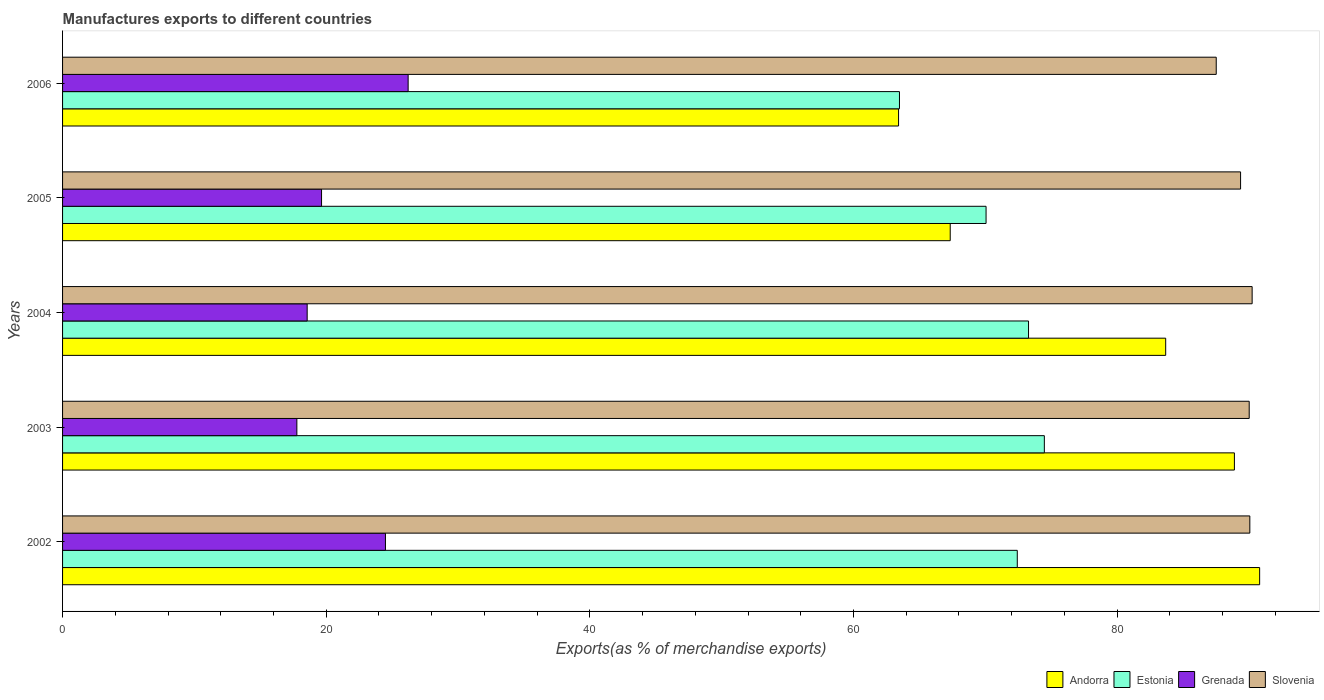How many different coloured bars are there?
Keep it short and to the point. 4. Are the number of bars per tick equal to the number of legend labels?
Provide a short and direct response. Yes. Are the number of bars on each tick of the Y-axis equal?
Provide a succinct answer. Yes. How many bars are there on the 3rd tick from the top?
Offer a terse response. 4. In how many cases, is the number of bars for a given year not equal to the number of legend labels?
Give a very brief answer. 0. What is the percentage of exports to different countries in Slovenia in 2005?
Provide a short and direct response. 89.36. Across all years, what is the maximum percentage of exports to different countries in Grenada?
Make the answer very short. 26.21. Across all years, what is the minimum percentage of exports to different countries in Slovenia?
Provide a succinct answer. 87.51. What is the total percentage of exports to different countries in Slovenia in the graph?
Your answer should be very brief. 447.19. What is the difference between the percentage of exports to different countries in Grenada in 2003 and that in 2004?
Your answer should be very brief. -0.78. What is the difference between the percentage of exports to different countries in Estonia in 2006 and the percentage of exports to different countries in Grenada in 2005?
Your response must be concise. 43.84. What is the average percentage of exports to different countries in Estonia per year?
Your answer should be very brief. 70.74. In the year 2006, what is the difference between the percentage of exports to different countries in Slovenia and percentage of exports to different countries in Andorra?
Provide a short and direct response. 24.1. What is the ratio of the percentage of exports to different countries in Grenada in 2003 to that in 2005?
Make the answer very short. 0.9. Is the percentage of exports to different countries in Andorra in 2002 less than that in 2005?
Ensure brevity in your answer.  No. Is the difference between the percentage of exports to different countries in Slovenia in 2002 and 2005 greater than the difference between the percentage of exports to different countries in Andorra in 2002 and 2005?
Make the answer very short. No. What is the difference between the highest and the second highest percentage of exports to different countries in Grenada?
Ensure brevity in your answer.  1.72. What is the difference between the highest and the lowest percentage of exports to different countries in Estonia?
Make the answer very short. 10.99. Is the sum of the percentage of exports to different countries in Andorra in 2002 and 2006 greater than the maximum percentage of exports to different countries in Slovenia across all years?
Your response must be concise. Yes. What does the 1st bar from the top in 2005 represents?
Keep it short and to the point. Slovenia. What does the 2nd bar from the bottom in 2005 represents?
Offer a terse response. Estonia. How many bars are there?
Ensure brevity in your answer.  20. Are all the bars in the graph horizontal?
Your response must be concise. Yes. Are the values on the major ticks of X-axis written in scientific E-notation?
Offer a very short reply. No. Does the graph contain any zero values?
Give a very brief answer. No. How are the legend labels stacked?
Give a very brief answer. Horizontal. What is the title of the graph?
Offer a terse response. Manufactures exports to different countries. What is the label or title of the X-axis?
Provide a short and direct response. Exports(as % of merchandise exports). What is the label or title of the Y-axis?
Ensure brevity in your answer.  Years. What is the Exports(as % of merchandise exports) in Andorra in 2002?
Ensure brevity in your answer.  90.81. What is the Exports(as % of merchandise exports) of Estonia in 2002?
Offer a terse response. 72.42. What is the Exports(as % of merchandise exports) of Grenada in 2002?
Ensure brevity in your answer.  24.49. What is the Exports(as % of merchandise exports) of Slovenia in 2002?
Offer a very short reply. 90.06. What is the Exports(as % of merchandise exports) of Andorra in 2003?
Your answer should be compact. 88.89. What is the Exports(as % of merchandise exports) of Estonia in 2003?
Offer a terse response. 74.48. What is the Exports(as % of merchandise exports) of Grenada in 2003?
Your answer should be compact. 17.77. What is the Exports(as % of merchandise exports) of Slovenia in 2003?
Offer a terse response. 90.02. What is the Exports(as % of merchandise exports) of Andorra in 2004?
Provide a short and direct response. 83.68. What is the Exports(as % of merchandise exports) of Estonia in 2004?
Offer a very short reply. 73.28. What is the Exports(as % of merchandise exports) of Grenada in 2004?
Your answer should be compact. 18.56. What is the Exports(as % of merchandise exports) of Slovenia in 2004?
Ensure brevity in your answer.  90.24. What is the Exports(as % of merchandise exports) in Andorra in 2005?
Give a very brief answer. 67.34. What is the Exports(as % of merchandise exports) in Estonia in 2005?
Offer a terse response. 70.05. What is the Exports(as % of merchandise exports) of Grenada in 2005?
Ensure brevity in your answer.  19.65. What is the Exports(as % of merchandise exports) in Slovenia in 2005?
Your answer should be compact. 89.36. What is the Exports(as % of merchandise exports) of Andorra in 2006?
Your answer should be very brief. 63.42. What is the Exports(as % of merchandise exports) in Estonia in 2006?
Offer a terse response. 63.49. What is the Exports(as % of merchandise exports) of Grenada in 2006?
Your response must be concise. 26.21. What is the Exports(as % of merchandise exports) in Slovenia in 2006?
Provide a short and direct response. 87.51. Across all years, what is the maximum Exports(as % of merchandise exports) of Andorra?
Offer a very short reply. 90.81. Across all years, what is the maximum Exports(as % of merchandise exports) of Estonia?
Your answer should be compact. 74.48. Across all years, what is the maximum Exports(as % of merchandise exports) of Grenada?
Provide a succinct answer. 26.21. Across all years, what is the maximum Exports(as % of merchandise exports) of Slovenia?
Provide a short and direct response. 90.24. Across all years, what is the minimum Exports(as % of merchandise exports) of Andorra?
Give a very brief answer. 63.42. Across all years, what is the minimum Exports(as % of merchandise exports) in Estonia?
Your answer should be compact. 63.49. Across all years, what is the minimum Exports(as % of merchandise exports) in Grenada?
Offer a very short reply. 17.77. Across all years, what is the minimum Exports(as % of merchandise exports) in Slovenia?
Give a very brief answer. 87.51. What is the total Exports(as % of merchandise exports) of Andorra in the graph?
Provide a short and direct response. 394.13. What is the total Exports(as % of merchandise exports) of Estonia in the graph?
Give a very brief answer. 353.71. What is the total Exports(as % of merchandise exports) in Grenada in the graph?
Ensure brevity in your answer.  106.68. What is the total Exports(as % of merchandise exports) in Slovenia in the graph?
Offer a terse response. 447.19. What is the difference between the Exports(as % of merchandise exports) of Andorra in 2002 and that in 2003?
Make the answer very short. 1.91. What is the difference between the Exports(as % of merchandise exports) of Estonia in 2002 and that in 2003?
Your answer should be very brief. -2.05. What is the difference between the Exports(as % of merchandise exports) of Grenada in 2002 and that in 2003?
Provide a succinct answer. 6.72. What is the difference between the Exports(as % of merchandise exports) in Slovenia in 2002 and that in 2003?
Your response must be concise. 0.05. What is the difference between the Exports(as % of merchandise exports) of Andorra in 2002 and that in 2004?
Make the answer very short. 7.13. What is the difference between the Exports(as % of merchandise exports) in Estonia in 2002 and that in 2004?
Your answer should be very brief. -0.85. What is the difference between the Exports(as % of merchandise exports) in Grenada in 2002 and that in 2004?
Your answer should be very brief. 5.94. What is the difference between the Exports(as % of merchandise exports) in Slovenia in 2002 and that in 2004?
Offer a very short reply. -0.18. What is the difference between the Exports(as % of merchandise exports) in Andorra in 2002 and that in 2005?
Give a very brief answer. 23.47. What is the difference between the Exports(as % of merchandise exports) in Estonia in 2002 and that in 2005?
Provide a short and direct response. 2.37. What is the difference between the Exports(as % of merchandise exports) of Grenada in 2002 and that in 2005?
Provide a succinct answer. 4.85. What is the difference between the Exports(as % of merchandise exports) of Slovenia in 2002 and that in 2005?
Your answer should be compact. 0.7. What is the difference between the Exports(as % of merchandise exports) in Andorra in 2002 and that in 2006?
Your answer should be compact. 27.39. What is the difference between the Exports(as % of merchandise exports) of Estonia in 2002 and that in 2006?
Your answer should be very brief. 8.94. What is the difference between the Exports(as % of merchandise exports) of Grenada in 2002 and that in 2006?
Make the answer very short. -1.72. What is the difference between the Exports(as % of merchandise exports) in Slovenia in 2002 and that in 2006?
Your response must be concise. 2.55. What is the difference between the Exports(as % of merchandise exports) in Andorra in 2003 and that in 2004?
Ensure brevity in your answer.  5.21. What is the difference between the Exports(as % of merchandise exports) of Estonia in 2003 and that in 2004?
Your answer should be very brief. 1.2. What is the difference between the Exports(as % of merchandise exports) of Grenada in 2003 and that in 2004?
Offer a very short reply. -0.78. What is the difference between the Exports(as % of merchandise exports) in Slovenia in 2003 and that in 2004?
Provide a short and direct response. -0.22. What is the difference between the Exports(as % of merchandise exports) of Andorra in 2003 and that in 2005?
Give a very brief answer. 21.56. What is the difference between the Exports(as % of merchandise exports) in Estonia in 2003 and that in 2005?
Make the answer very short. 4.42. What is the difference between the Exports(as % of merchandise exports) of Grenada in 2003 and that in 2005?
Offer a very short reply. -1.87. What is the difference between the Exports(as % of merchandise exports) in Slovenia in 2003 and that in 2005?
Your response must be concise. 0.65. What is the difference between the Exports(as % of merchandise exports) of Andorra in 2003 and that in 2006?
Ensure brevity in your answer.  25.48. What is the difference between the Exports(as % of merchandise exports) of Estonia in 2003 and that in 2006?
Your response must be concise. 10.99. What is the difference between the Exports(as % of merchandise exports) of Grenada in 2003 and that in 2006?
Your answer should be compact. -8.44. What is the difference between the Exports(as % of merchandise exports) of Slovenia in 2003 and that in 2006?
Provide a succinct answer. 2.5. What is the difference between the Exports(as % of merchandise exports) of Andorra in 2004 and that in 2005?
Offer a very short reply. 16.34. What is the difference between the Exports(as % of merchandise exports) in Estonia in 2004 and that in 2005?
Offer a very short reply. 3.22. What is the difference between the Exports(as % of merchandise exports) of Grenada in 2004 and that in 2005?
Provide a short and direct response. -1.09. What is the difference between the Exports(as % of merchandise exports) of Slovenia in 2004 and that in 2005?
Make the answer very short. 0.88. What is the difference between the Exports(as % of merchandise exports) in Andorra in 2004 and that in 2006?
Give a very brief answer. 20.26. What is the difference between the Exports(as % of merchandise exports) in Estonia in 2004 and that in 2006?
Your answer should be compact. 9.79. What is the difference between the Exports(as % of merchandise exports) in Grenada in 2004 and that in 2006?
Your answer should be very brief. -7.66. What is the difference between the Exports(as % of merchandise exports) in Slovenia in 2004 and that in 2006?
Ensure brevity in your answer.  2.72. What is the difference between the Exports(as % of merchandise exports) of Andorra in 2005 and that in 2006?
Offer a very short reply. 3.92. What is the difference between the Exports(as % of merchandise exports) in Estonia in 2005 and that in 2006?
Your answer should be compact. 6.57. What is the difference between the Exports(as % of merchandise exports) of Grenada in 2005 and that in 2006?
Provide a short and direct response. -6.57. What is the difference between the Exports(as % of merchandise exports) in Slovenia in 2005 and that in 2006?
Your answer should be very brief. 1.85. What is the difference between the Exports(as % of merchandise exports) of Andorra in 2002 and the Exports(as % of merchandise exports) of Estonia in 2003?
Offer a terse response. 16.33. What is the difference between the Exports(as % of merchandise exports) of Andorra in 2002 and the Exports(as % of merchandise exports) of Grenada in 2003?
Offer a very short reply. 73.03. What is the difference between the Exports(as % of merchandise exports) in Andorra in 2002 and the Exports(as % of merchandise exports) in Slovenia in 2003?
Your answer should be very brief. 0.79. What is the difference between the Exports(as % of merchandise exports) of Estonia in 2002 and the Exports(as % of merchandise exports) of Grenada in 2003?
Your answer should be very brief. 54.65. What is the difference between the Exports(as % of merchandise exports) of Estonia in 2002 and the Exports(as % of merchandise exports) of Slovenia in 2003?
Your answer should be very brief. -17.59. What is the difference between the Exports(as % of merchandise exports) of Grenada in 2002 and the Exports(as % of merchandise exports) of Slovenia in 2003?
Your response must be concise. -65.52. What is the difference between the Exports(as % of merchandise exports) of Andorra in 2002 and the Exports(as % of merchandise exports) of Estonia in 2004?
Provide a succinct answer. 17.53. What is the difference between the Exports(as % of merchandise exports) of Andorra in 2002 and the Exports(as % of merchandise exports) of Grenada in 2004?
Make the answer very short. 72.25. What is the difference between the Exports(as % of merchandise exports) of Andorra in 2002 and the Exports(as % of merchandise exports) of Slovenia in 2004?
Provide a short and direct response. 0.57. What is the difference between the Exports(as % of merchandise exports) in Estonia in 2002 and the Exports(as % of merchandise exports) in Grenada in 2004?
Make the answer very short. 53.87. What is the difference between the Exports(as % of merchandise exports) of Estonia in 2002 and the Exports(as % of merchandise exports) of Slovenia in 2004?
Provide a short and direct response. -17.82. What is the difference between the Exports(as % of merchandise exports) of Grenada in 2002 and the Exports(as % of merchandise exports) of Slovenia in 2004?
Provide a succinct answer. -65.75. What is the difference between the Exports(as % of merchandise exports) in Andorra in 2002 and the Exports(as % of merchandise exports) in Estonia in 2005?
Your answer should be compact. 20.75. What is the difference between the Exports(as % of merchandise exports) of Andorra in 2002 and the Exports(as % of merchandise exports) of Grenada in 2005?
Make the answer very short. 71.16. What is the difference between the Exports(as % of merchandise exports) of Andorra in 2002 and the Exports(as % of merchandise exports) of Slovenia in 2005?
Your response must be concise. 1.45. What is the difference between the Exports(as % of merchandise exports) of Estonia in 2002 and the Exports(as % of merchandise exports) of Grenada in 2005?
Ensure brevity in your answer.  52.78. What is the difference between the Exports(as % of merchandise exports) in Estonia in 2002 and the Exports(as % of merchandise exports) in Slovenia in 2005?
Provide a succinct answer. -16.94. What is the difference between the Exports(as % of merchandise exports) of Grenada in 2002 and the Exports(as % of merchandise exports) of Slovenia in 2005?
Your answer should be compact. -64.87. What is the difference between the Exports(as % of merchandise exports) of Andorra in 2002 and the Exports(as % of merchandise exports) of Estonia in 2006?
Keep it short and to the point. 27.32. What is the difference between the Exports(as % of merchandise exports) in Andorra in 2002 and the Exports(as % of merchandise exports) in Grenada in 2006?
Ensure brevity in your answer.  64.59. What is the difference between the Exports(as % of merchandise exports) of Andorra in 2002 and the Exports(as % of merchandise exports) of Slovenia in 2006?
Ensure brevity in your answer.  3.29. What is the difference between the Exports(as % of merchandise exports) in Estonia in 2002 and the Exports(as % of merchandise exports) in Grenada in 2006?
Ensure brevity in your answer.  46.21. What is the difference between the Exports(as % of merchandise exports) of Estonia in 2002 and the Exports(as % of merchandise exports) of Slovenia in 2006?
Provide a succinct answer. -15.09. What is the difference between the Exports(as % of merchandise exports) in Grenada in 2002 and the Exports(as % of merchandise exports) in Slovenia in 2006?
Provide a short and direct response. -63.02. What is the difference between the Exports(as % of merchandise exports) of Andorra in 2003 and the Exports(as % of merchandise exports) of Estonia in 2004?
Your response must be concise. 15.62. What is the difference between the Exports(as % of merchandise exports) in Andorra in 2003 and the Exports(as % of merchandise exports) in Grenada in 2004?
Your answer should be compact. 70.34. What is the difference between the Exports(as % of merchandise exports) of Andorra in 2003 and the Exports(as % of merchandise exports) of Slovenia in 2004?
Keep it short and to the point. -1.35. What is the difference between the Exports(as % of merchandise exports) of Estonia in 2003 and the Exports(as % of merchandise exports) of Grenada in 2004?
Your answer should be compact. 55.92. What is the difference between the Exports(as % of merchandise exports) in Estonia in 2003 and the Exports(as % of merchandise exports) in Slovenia in 2004?
Offer a very short reply. -15.76. What is the difference between the Exports(as % of merchandise exports) in Grenada in 2003 and the Exports(as % of merchandise exports) in Slovenia in 2004?
Keep it short and to the point. -72.47. What is the difference between the Exports(as % of merchandise exports) of Andorra in 2003 and the Exports(as % of merchandise exports) of Estonia in 2005?
Offer a terse response. 18.84. What is the difference between the Exports(as % of merchandise exports) in Andorra in 2003 and the Exports(as % of merchandise exports) in Grenada in 2005?
Keep it short and to the point. 69.25. What is the difference between the Exports(as % of merchandise exports) of Andorra in 2003 and the Exports(as % of merchandise exports) of Slovenia in 2005?
Keep it short and to the point. -0.47. What is the difference between the Exports(as % of merchandise exports) in Estonia in 2003 and the Exports(as % of merchandise exports) in Grenada in 2005?
Give a very brief answer. 54.83. What is the difference between the Exports(as % of merchandise exports) of Estonia in 2003 and the Exports(as % of merchandise exports) of Slovenia in 2005?
Offer a very short reply. -14.89. What is the difference between the Exports(as % of merchandise exports) of Grenada in 2003 and the Exports(as % of merchandise exports) of Slovenia in 2005?
Offer a very short reply. -71.59. What is the difference between the Exports(as % of merchandise exports) of Andorra in 2003 and the Exports(as % of merchandise exports) of Estonia in 2006?
Give a very brief answer. 25.41. What is the difference between the Exports(as % of merchandise exports) in Andorra in 2003 and the Exports(as % of merchandise exports) in Grenada in 2006?
Your answer should be very brief. 62.68. What is the difference between the Exports(as % of merchandise exports) in Andorra in 2003 and the Exports(as % of merchandise exports) in Slovenia in 2006?
Keep it short and to the point. 1.38. What is the difference between the Exports(as % of merchandise exports) of Estonia in 2003 and the Exports(as % of merchandise exports) of Grenada in 2006?
Offer a terse response. 48.26. What is the difference between the Exports(as % of merchandise exports) of Estonia in 2003 and the Exports(as % of merchandise exports) of Slovenia in 2006?
Ensure brevity in your answer.  -13.04. What is the difference between the Exports(as % of merchandise exports) of Grenada in 2003 and the Exports(as % of merchandise exports) of Slovenia in 2006?
Your response must be concise. -69.74. What is the difference between the Exports(as % of merchandise exports) in Andorra in 2004 and the Exports(as % of merchandise exports) in Estonia in 2005?
Your response must be concise. 13.63. What is the difference between the Exports(as % of merchandise exports) in Andorra in 2004 and the Exports(as % of merchandise exports) in Grenada in 2005?
Provide a succinct answer. 64.03. What is the difference between the Exports(as % of merchandise exports) in Andorra in 2004 and the Exports(as % of merchandise exports) in Slovenia in 2005?
Provide a succinct answer. -5.68. What is the difference between the Exports(as % of merchandise exports) of Estonia in 2004 and the Exports(as % of merchandise exports) of Grenada in 2005?
Make the answer very short. 53.63. What is the difference between the Exports(as % of merchandise exports) of Estonia in 2004 and the Exports(as % of merchandise exports) of Slovenia in 2005?
Keep it short and to the point. -16.09. What is the difference between the Exports(as % of merchandise exports) in Grenada in 2004 and the Exports(as % of merchandise exports) in Slovenia in 2005?
Provide a succinct answer. -70.81. What is the difference between the Exports(as % of merchandise exports) of Andorra in 2004 and the Exports(as % of merchandise exports) of Estonia in 2006?
Your answer should be compact. 20.19. What is the difference between the Exports(as % of merchandise exports) of Andorra in 2004 and the Exports(as % of merchandise exports) of Grenada in 2006?
Your answer should be very brief. 57.47. What is the difference between the Exports(as % of merchandise exports) of Andorra in 2004 and the Exports(as % of merchandise exports) of Slovenia in 2006?
Ensure brevity in your answer.  -3.83. What is the difference between the Exports(as % of merchandise exports) of Estonia in 2004 and the Exports(as % of merchandise exports) of Grenada in 2006?
Provide a succinct answer. 47.06. What is the difference between the Exports(as % of merchandise exports) in Estonia in 2004 and the Exports(as % of merchandise exports) in Slovenia in 2006?
Keep it short and to the point. -14.24. What is the difference between the Exports(as % of merchandise exports) of Grenada in 2004 and the Exports(as % of merchandise exports) of Slovenia in 2006?
Provide a succinct answer. -68.96. What is the difference between the Exports(as % of merchandise exports) of Andorra in 2005 and the Exports(as % of merchandise exports) of Estonia in 2006?
Give a very brief answer. 3.85. What is the difference between the Exports(as % of merchandise exports) of Andorra in 2005 and the Exports(as % of merchandise exports) of Grenada in 2006?
Provide a succinct answer. 41.12. What is the difference between the Exports(as % of merchandise exports) of Andorra in 2005 and the Exports(as % of merchandise exports) of Slovenia in 2006?
Offer a terse response. -20.18. What is the difference between the Exports(as % of merchandise exports) of Estonia in 2005 and the Exports(as % of merchandise exports) of Grenada in 2006?
Provide a short and direct response. 43.84. What is the difference between the Exports(as % of merchandise exports) in Estonia in 2005 and the Exports(as % of merchandise exports) in Slovenia in 2006?
Give a very brief answer. -17.46. What is the difference between the Exports(as % of merchandise exports) of Grenada in 2005 and the Exports(as % of merchandise exports) of Slovenia in 2006?
Offer a terse response. -67.87. What is the average Exports(as % of merchandise exports) in Andorra per year?
Provide a succinct answer. 78.83. What is the average Exports(as % of merchandise exports) of Estonia per year?
Offer a terse response. 70.74. What is the average Exports(as % of merchandise exports) in Grenada per year?
Keep it short and to the point. 21.34. What is the average Exports(as % of merchandise exports) of Slovenia per year?
Make the answer very short. 89.44. In the year 2002, what is the difference between the Exports(as % of merchandise exports) in Andorra and Exports(as % of merchandise exports) in Estonia?
Your answer should be very brief. 18.38. In the year 2002, what is the difference between the Exports(as % of merchandise exports) in Andorra and Exports(as % of merchandise exports) in Grenada?
Offer a terse response. 66.31. In the year 2002, what is the difference between the Exports(as % of merchandise exports) of Andorra and Exports(as % of merchandise exports) of Slovenia?
Offer a terse response. 0.74. In the year 2002, what is the difference between the Exports(as % of merchandise exports) of Estonia and Exports(as % of merchandise exports) of Grenada?
Offer a very short reply. 47.93. In the year 2002, what is the difference between the Exports(as % of merchandise exports) in Estonia and Exports(as % of merchandise exports) in Slovenia?
Provide a short and direct response. -17.64. In the year 2002, what is the difference between the Exports(as % of merchandise exports) of Grenada and Exports(as % of merchandise exports) of Slovenia?
Offer a terse response. -65.57. In the year 2003, what is the difference between the Exports(as % of merchandise exports) in Andorra and Exports(as % of merchandise exports) in Estonia?
Make the answer very short. 14.42. In the year 2003, what is the difference between the Exports(as % of merchandise exports) in Andorra and Exports(as % of merchandise exports) in Grenada?
Your answer should be compact. 71.12. In the year 2003, what is the difference between the Exports(as % of merchandise exports) in Andorra and Exports(as % of merchandise exports) in Slovenia?
Your answer should be very brief. -1.12. In the year 2003, what is the difference between the Exports(as % of merchandise exports) in Estonia and Exports(as % of merchandise exports) in Grenada?
Make the answer very short. 56.7. In the year 2003, what is the difference between the Exports(as % of merchandise exports) in Estonia and Exports(as % of merchandise exports) in Slovenia?
Ensure brevity in your answer.  -15.54. In the year 2003, what is the difference between the Exports(as % of merchandise exports) of Grenada and Exports(as % of merchandise exports) of Slovenia?
Offer a terse response. -72.24. In the year 2004, what is the difference between the Exports(as % of merchandise exports) in Andorra and Exports(as % of merchandise exports) in Estonia?
Offer a terse response. 10.4. In the year 2004, what is the difference between the Exports(as % of merchandise exports) in Andorra and Exports(as % of merchandise exports) in Grenada?
Provide a succinct answer. 65.12. In the year 2004, what is the difference between the Exports(as % of merchandise exports) of Andorra and Exports(as % of merchandise exports) of Slovenia?
Make the answer very short. -6.56. In the year 2004, what is the difference between the Exports(as % of merchandise exports) in Estonia and Exports(as % of merchandise exports) in Grenada?
Keep it short and to the point. 54.72. In the year 2004, what is the difference between the Exports(as % of merchandise exports) in Estonia and Exports(as % of merchandise exports) in Slovenia?
Give a very brief answer. -16.96. In the year 2004, what is the difference between the Exports(as % of merchandise exports) in Grenada and Exports(as % of merchandise exports) in Slovenia?
Give a very brief answer. -71.68. In the year 2005, what is the difference between the Exports(as % of merchandise exports) in Andorra and Exports(as % of merchandise exports) in Estonia?
Your answer should be very brief. -2.72. In the year 2005, what is the difference between the Exports(as % of merchandise exports) in Andorra and Exports(as % of merchandise exports) in Grenada?
Provide a succinct answer. 47.69. In the year 2005, what is the difference between the Exports(as % of merchandise exports) in Andorra and Exports(as % of merchandise exports) in Slovenia?
Make the answer very short. -22.03. In the year 2005, what is the difference between the Exports(as % of merchandise exports) in Estonia and Exports(as % of merchandise exports) in Grenada?
Make the answer very short. 50.41. In the year 2005, what is the difference between the Exports(as % of merchandise exports) of Estonia and Exports(as % of merchandise exports) of Slovenia?
Keep it short and to the point. -19.31. In the year 2005, what is the difference between the Exports(as % of merchandise exports) of Grenada and Exports(as % of merchandise exports) of Slovenia?
Make the answer very short. -69.72. In the year 2006, what is the difference between the Exports(as % of merchandise exports) in Andorra and Exports(as % of merchandise exports) in Estonia?
Your answer should be very brief. -0.07. In the year 2006, what is the difference between the Exports(as % of merchandise exports) of Andorra and Exports(as % of merchandise exports) of Grenada?
Your answer should be very brief. 37.2. In the year 2006, what is the difference between the Exports(as % of merchandise exports) in Andorra and Exports(as % of merchandise exports) in Slovenia?
Give a very brief answer. -24.1. In the year 2006, what is the difference between the Exports(as % of merchandise exports) of Estonia and Exports(as % of merchandise exports) of Grenada?
Provide a short and direct response. 37.27. In the year 2006, what is the difference between the Exports(as % of merchandise exports) of Estonia and Exports(as % of merchandise exports) of Slovenia?
Keep it short and to the point. -24.03. In the year 2006, what is the difference between the Exports(as % of merchandise exports) in Grenada and Exports(as % of merchandise exports) in Slovenia?
Your answer should be very brief. -61.3. What is the ratio of the Exports(as % of merchandise exports) of Andorra in 2002 to that in 2003?
Your response must be concise. 1.02. What is the ratio of the Exports(as % of merchandise exports) of Estonia in 2002 to that in 2003?
Give a very brief answer. 0.97. What is the ratio of the Exports(as % of merchandise exports) in Grenada in 2002 to that in 2003?
Your answer should be compact. 1.38. What is the ratio of the Exports(as % of merchandise exports) in Slovenia in 2002 to that in 2003?
Ensure brevity in your answer.  1. What is the ratio of the Exports(as % of merchandise exports) in Andorra in 2002 to that in 2004?
Make the answer very short. 1.09. What is the ratio of the Exports(as % of merchandise exports) of Estonia in 2002 to that in 2004?
Provide a succinct answer. 0.99. What is the ratio of the Exports(as % of merchandise exports) in Grenada in 2002 to that in 2004?
Provide a short and direct response. 1.32. What is the ratio of the Exports(as % of merchandise exports) in Andorra in 2002 to that in 2005?
Offer a terse response. 1.35. What is the ratio of the Exports(as % of merchandise exports) in Estonia in 2002 to that in 2005?
Make the answer very short. 1.03. What is the ratio of the Exports(as % of merchandise exports) of Grenada in 2002 to that in 2005?
Make the answer very short. 1.25. What is the ratio of the Exports(as % of merchandise exports) in Slovenia in 2002 to that in 2005?
Keep it short and to the point. 1.01. What is the ratio of the Exports(as % of merchandise exports) of Andorra in 2002 to that in 2006?
Your response must be concise. 1.43. What is the ratio of the Exports(as % of merchandise exports) of Estonia in 2002 to that in 2006?
Keep it short and to the point. 1.14. What is the ratio of the Exports(as % of merchandise exports) of Grenada in 2002 to that in 2006?
Give a very brief answer. 0.93. What is the ratio of the Exports(as % of merchandise exports) in Slovenia in 2002 to that in 2006?
Provide a succinct answer. 1.03. What is the ratio of the Exports(as % of merchandise exports) of Andorra in 2003 to that in 2004?
Offer a terse response. 1.06. What is the ratio of the Exports(as % of merchandise exports) in Estonia in 2003 to that in 2004?
Your response must be concise. 1.02. What is the ratio of the Exports(as % of merchandise exports) of Grenada in 2003 to that in 2004?
Ensure brevity in your answer.  0.96. What is the ratio of the Exports(as % of merchandise exports) of Slovenia in 2003 to that in 2004?
Make the answer very short. 1. What is the ratio of the Exports(as % of merchandise exports) of Andorra in 2003 to that in 2005?
Ensure brevity in your answer.  1.32. What is the ratio of the Exports(as % of merchandise exports) of Estonia in 2003 to that in 2005?
Your response must be concise. 1.06. What is the ratio of the Exports(as % of merchandise exports) in Grenada in 2003 to that in 2005?
Ensure brevity in your answer.  0.9. What is the ratio of the Exports(as % of merchandise exports) in Slovenia in 2003 to that in 2005?
Your answer should be compact. 1.01. What is the ratio of the Exports(as % of merchandise exports) in Andorra in 2003 to that in 2006?
Offer a terse response. 1.4. What is the ratio of the Exports(as % of merchandise exports) of Estonia in 2003 to that in 2006?
Offer a very short reply. 1.17. What is the ratio of the Exports(as % of merchandise exports) in Grenada in 2003 to that in 2006?
Your response must be concise. 0.68. What is the ratio of the Exports(as % of merchandise exports) in Slovenia in 2003 to that in 2006?
Your response must be concise. 1.03. What is the ratio of the Exports(as % of merchandise exports) of Andorra in 2004 to that in 2005?
Provide a short and direct response. 1.24. What is the ratio of the Exports(as % of merchandise exports) in Estonia in 2004 to that in 2005?
Make the answer very short. 1.05. What is the ratio of the Exports(as % of merchandise exports) of Grenada in 2004 to that in 2005?
Offer a very short reply. 0.94. What is the ratio of the Exports(as % of merchandise exports) of Slovenia in 2004 to that in 2005?
Give a very brief answer. 1.01. What is the ratio of the Exports(as % of merchandise exports) of Andorra in 2004 to that in 2006?
Your answer should be very brief. 1.32. What is the ratio of the Exports(as % of merchandise exports) of Estonia in 2004 to that in 2006?
Offer a very short reply. 1.15. What is the ratio of the Exports(as % of merchandise exports) of Grenada in 2004 to that in 2006?
Give a very brief answer. 0.71. What is the ratio of the Exports(as % of merchandise exports) of Slovenia in 2004 to that in 2006?
Provide a succinct answer. 1.03. What is the ratio of the Exports(as % of merchandise exports) of Andorra in 2005 to that in 2006?
Provide a short and direct response. 1.06. What is the ratio of the Exports(as % of merchandise exports) of Estonia in 2005 to that in 2006?
Offer a very short reply. 1.1. What is the ratio of the Exports(as % of merchandise exports) of Grenada in 2005 to that in 2006?
Ensure brevity in your answer.  0.75. What is the ratio of the Exports(as % of merchandise exports) in Slovenia in 2005 to that in 2006?
Ensure brevity in your answer.  1.02. What is the difference between the highest and the second highest Exports(as % of merchandise exports) of Andorra?
Provide a succinct answer. 1.91. What is the difference between the highest and the second highest Exports(as % of merchandise exports) in Estonia?
Your answer should be very brief. 1.2. What is the difference between the highest and the second highest Exports(as % of merchandise exports) in Grenada?
Your response must be concise. 1.72. What is the difference between the highest and the second highest Exports(as % of merchandise exports) in Slovenia?
Provide a succinct answer. 0.18. What is the difference between the highest and the lowest Exports(as % of merchandise exports) in Andorra?
Make the answer very short. 27.39. What is the difference between the highest and the lowest Exports(as % of merchandise exports) in Estonia?
Offer a terse response. 10.99. What is the difference between the highest and the lowest Exports(as % of merchandise exports) of Grenada?
Offer a terse response. 8.44. What is the difference between the highest and the lowest Exports(as % of merchandise exports) of Slovenia?
Provide a succinct answer. 2.72. 